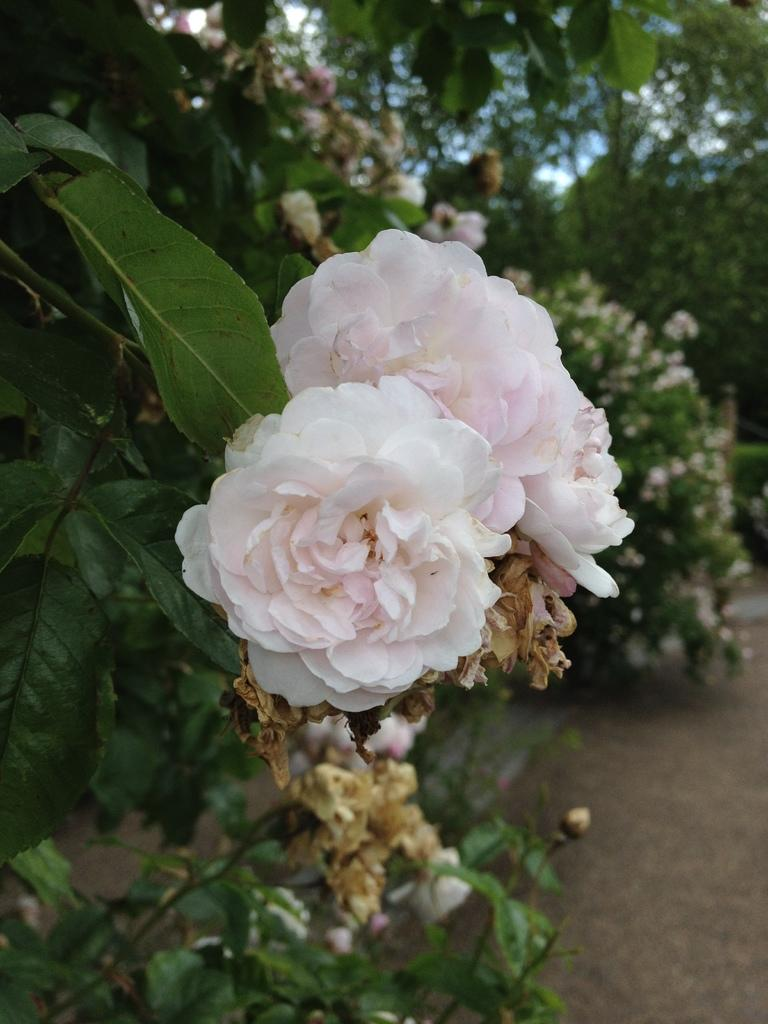What type of plants can be seen in the image? There are plants with flowers in the image. What can be seen in the background of the image? There are trees in the background of the image. What type of toy is placed on the birthday cake in the image? There is no toy or birthday cake present in the image; it features plants with flowers and trees in the background. 